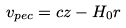<formula> <loc_0><loc_0><loc_500><loc_500>v _ { p e c } = c z - H _ { 0 } r</formula> 